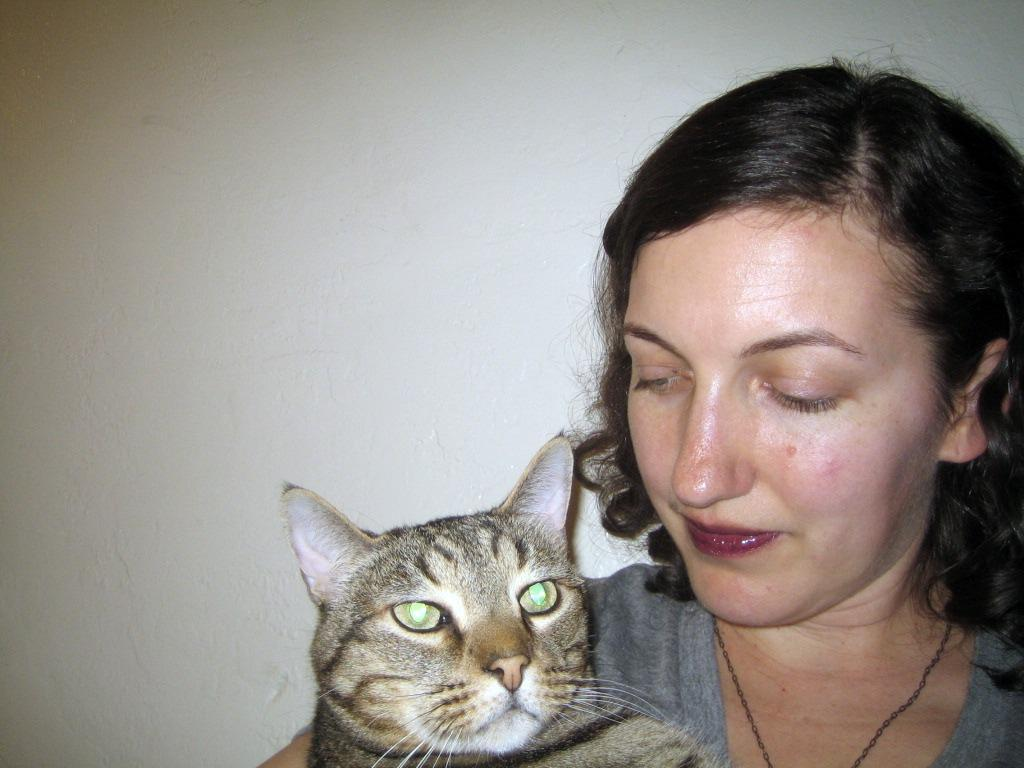Who is present in the image? There is a woman in the image. What is the woman wearing? The woman is wearing a grey dress. What is the woman holding in the image? The woman is holding a cat. What can be seen in the background of the image? There is a wall visible in the background of the image. What type of fork is being used to exchange captions with the cat in the image? There is no fork or caption exchange present in the image; the woman is simply holding a cat. 